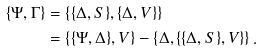Convert formula to latex. <formula><loc_0><loc_0><loc_500><loc_500>\{ \Psi , \Gamma \} & = \left \{ \{ \Delta , S \} , \{ \Delta , V \} \right \} \\ & = \left \{ \{ \Psi , \Delta \} , V \right \} - \left \{ \Delta , \{ \{ \Delta , S \} , V \} \right \} .</formula> 